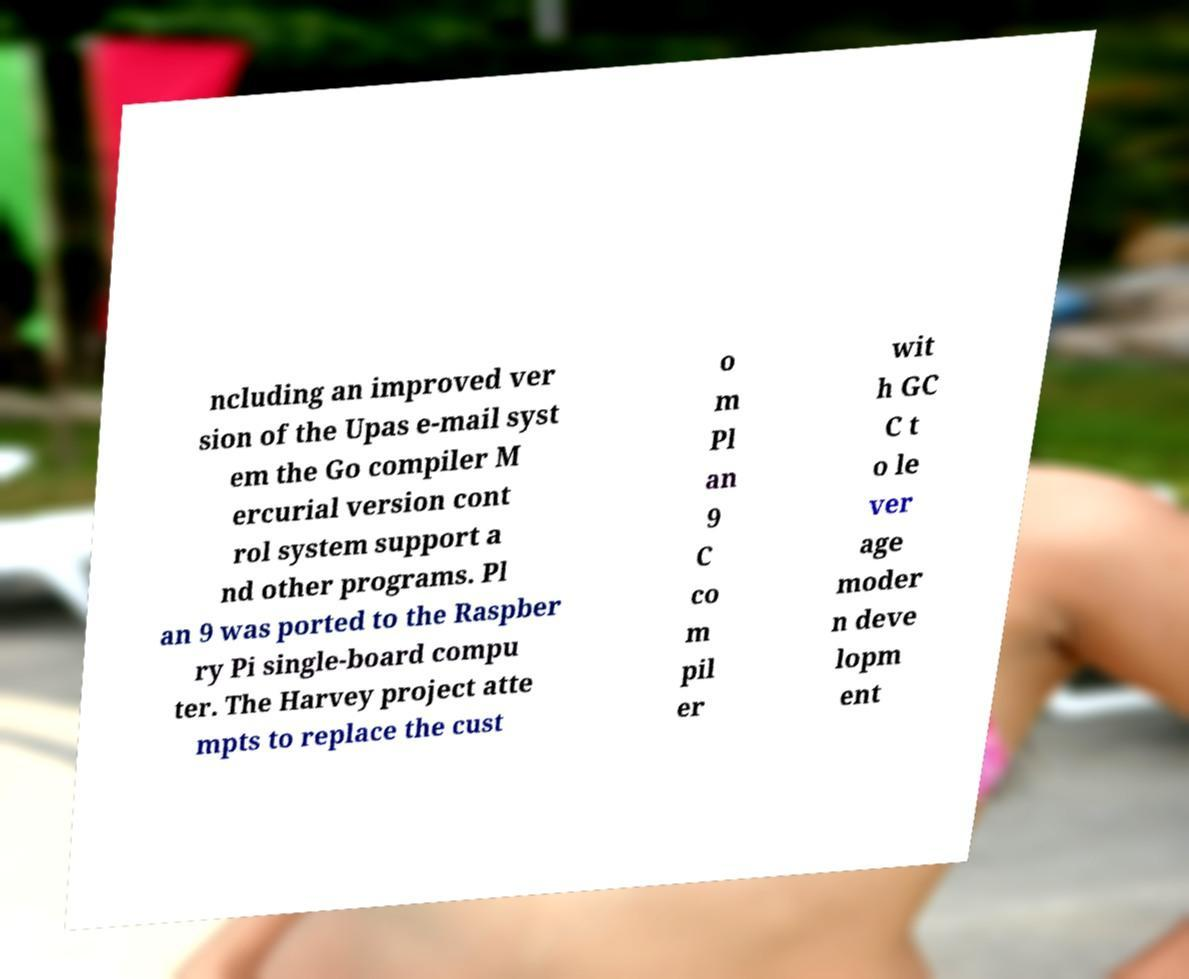I need the written content from this picture converted into text. Can you do that? ncluding an improved ver sion of the Upas e-mail syst em the Go compiler M ercurial version cont rol system support a nd other programs. Pl an 9 was ported to the Raspber ry Pi single-board compu ter. The Harvey project atte mpts to replace the cust o m Pl an 9 C co m pil er wit h GC C t o le ver age moder n deve lopm ent 